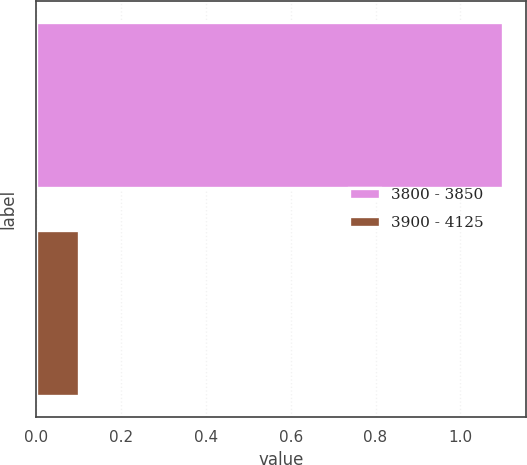Convert chart to OTSL. <chart><loc_0><loc_0><loc_500><loc_500><bar_chart><fcel>3800 - 3850<fcel>3900 - 4125<nl><fcel>1.1<fcel>0.1<nl></chart> 